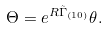<formula> <loc_0><loc_0><loc_500><loc_500>\Theta = { e ^ { R \tilde { \Gamma } _ { ( 1 0 ) } } \theta } .</formula> 